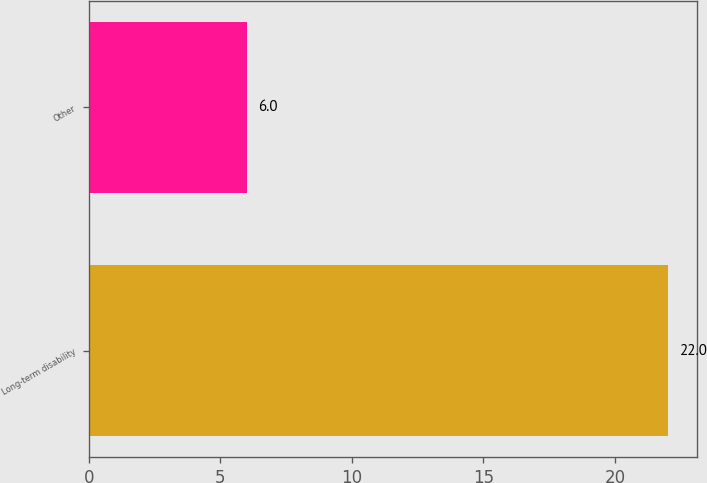<chart> <loc_0><loc_0><loc_500><loc_500><bar_chart><fcel>Long-term disability<fcel>Other<nl><fcel>22<fcel>6<nl></chart> 